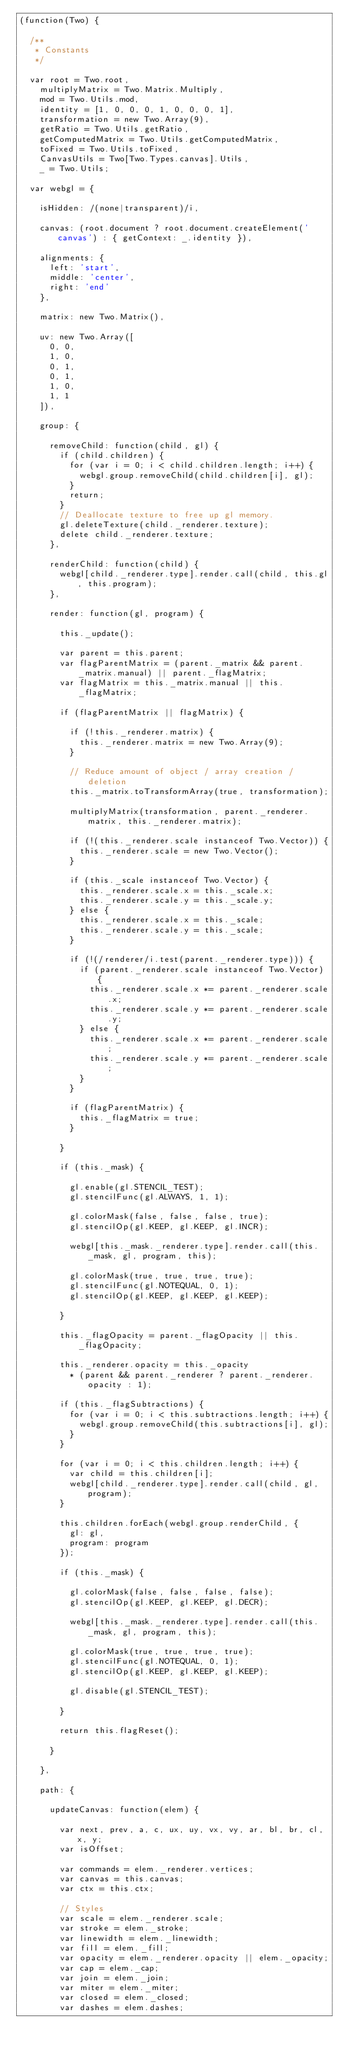<code> <loc_0><loc_0><loc_500><loc_500><_JavaScript_>(function(Two) {

  /**
   * Constants
   */

  var root = Two.root,
    multiplyMatrix = Two.Matrix.Multiply,
    mod = Two.Utils.mod,
    identity = [1, 0, 0, 0, 1, 0, 0, 0, 1],
    transformation = new Two.Array(9),
    getRatio = Two.Utils.getRatio,
    getComputedMatrix = Two.Utils.getComputedMatrix,
    toFixed = Two.Utils.toFixed,
    CanvasUtils = Two[Two.Types.canvas].Utils,
    _ = Two.Utils;

  var webgl = {

    isHidden: /(none|transparent)/i,

    canvas: (root.document ? root.document.createElement('canvas') : { getContext: _.identity }),

    alignments: {
      left: 'start',
      middle: 'center',
      right: 'end'
    },

    matrix: new Two.Matrix(),

    uv: new Two.Array([
      0, 0,
      1, 0,
      0, 1,
      0, 1,
      1, 0,
      1, 1
    ]),

    group: {

      removeChild: function(child, gl) {
        if (child.children) {
          for (var i = 0; i < child.children.length; i++) {
            webgl.group.removeChild(child.children[i], gl);
          }
          return;
        }
        // Deallocate texture to free up gl memory.
        gl.deleteTexture(child._renderer.texture);
        delete child._renderer.texture;
      },

      renderChild: function(child) {
        webgl[child._renderer.type].render.call(child, this.gl, this.program);
      },

      render: function(gl, program) {

        this._update();

        var parent = this.parent;
        var flagParentMatrix = (parent._matrix && parent._matrix.manual) || parent._flagMatrix;
        var flagMatrix = this._matrix.manual || this._flagMatrix;

        if (flagParentMatrix || flagMatrix) {

          if (!this._renderer.matrix) {
            this._renderer.matrix = new Two.Array(9);
          }

          // Reduce amount of object / array creation / deletion
          this._matrix.toTransformArray(true, transformation);

          multiplyMatrix(transformation, parent._renderer.matrix, this._renderer.matrix);

          if (!(this._renderer.scale instanceof Two.Vector)) {
            this._renderer.scale = new Two.Vector();
          }

          if (this._scale instanceof Two.Vector) {
            this._renderer.scale.x = this._scale.x;
            this._renderer.scale.y = this._scale.y;
          } else {
            this._renderer.scale.x = this._scale;
            this._renderer.scale.y = this._scale;
          }

          if (!(/renderer/i.test(parent._renderer.type))) {
            if (parent._renderer.scale instanceof Two.Vector) {
              this._renderer.scale.x *= parent._renderer.scale.x;
              this._renderer.scale.y *= parent._renderer.scale.y;
            } else {
              this._renderer.scale.x *= parent._renderer.scale;
              this._renderer.scale.y *= parent._renderer.scale;
            }
          }

          if (flagParentMatrix) {
            this._flagMatrix = true;
          }

        }

        if (this._mask) {

          gl.enable(gl.STENCIL_TEST);
          gl.stencilFunc(gl.ALWAYS, 1, 1);

          gl.colorMask(false, false, false, true);
          gl.stencilOp(gl.KEEP, gl.KEEP, gl.INCR);

          webgl[this._mask._renderer.type].render.call(this._mask, gl, program, this);

          gl.colorMask(true, true, true, true);
          gl.stencilFunc(gl.NOTEQUAL, 0, 1);
          gl.stencilOp(gl.KEEP, gl.KEEP, gl.KEEP);

        }

        this._flagOpacity = parent._flagOpacity || this._flagOpacity;

        this._renderer.opacity = this._opacity
          * (parent && parent._renderer ? parent._renderer.opacity : 1);

        if (this._flagSubtractions) {
          for (var i = 0; i < this.subtractions.length; i++) {
            webgl.group.removeChild(this.subtractions[i], gl);
          }
        }

        for (var i = 0; i < this.children.length; i++) {
          var child = this.children[i];
          webgl[child._renderer.type].render.call(child, gl, program);
        }

        this.children.forEach(webgl.group.renderChild, {
          gl: gl,
          program: program
        });

        if (this._mask) {

          gl.colorMask(false, false, false, false);
          gl.stencilOp(gl.KEEP, gl.KEEP, gl.DECR);

          webgl[this._mask._renderer.type].render.call(this._mask, gl, program, this);

          gl.colorMask(true, true, true, true);
          gl.stencilFunc(gl.NOTEQUAL, 0, 1);
          gl.stencilOp(gl.KEEP, gl.KEEP, gl.KEEP);

          gl.disable(gl.STENCIL_TEST);

        }

        return this.flagReset();

      }

    },

    path: {

      updateCanvas: function(elem) {

        var next, prev, a, c, ux, uy, vx, vy, ar, bl, br, cl, x, y;
        var isOffset;

        var commands = elem._renderer.vertices;
        var canvas = this.canvas;
        var ctx = this.ctx;

        // Styles
        var scale = elem._renderer.scale;
        var stroke = elem._stroke;
        var linewidth = elem._linewidth;
        var fill = elem._fill;
        var opacity = elem._renderer.opacity || elem._opacity;
        var cap = elem._cap;
        var join = elem._join;
        var miter = elem._miter;
        var closed = elem._closed;
        var dashes = elem.dashes;</code> 